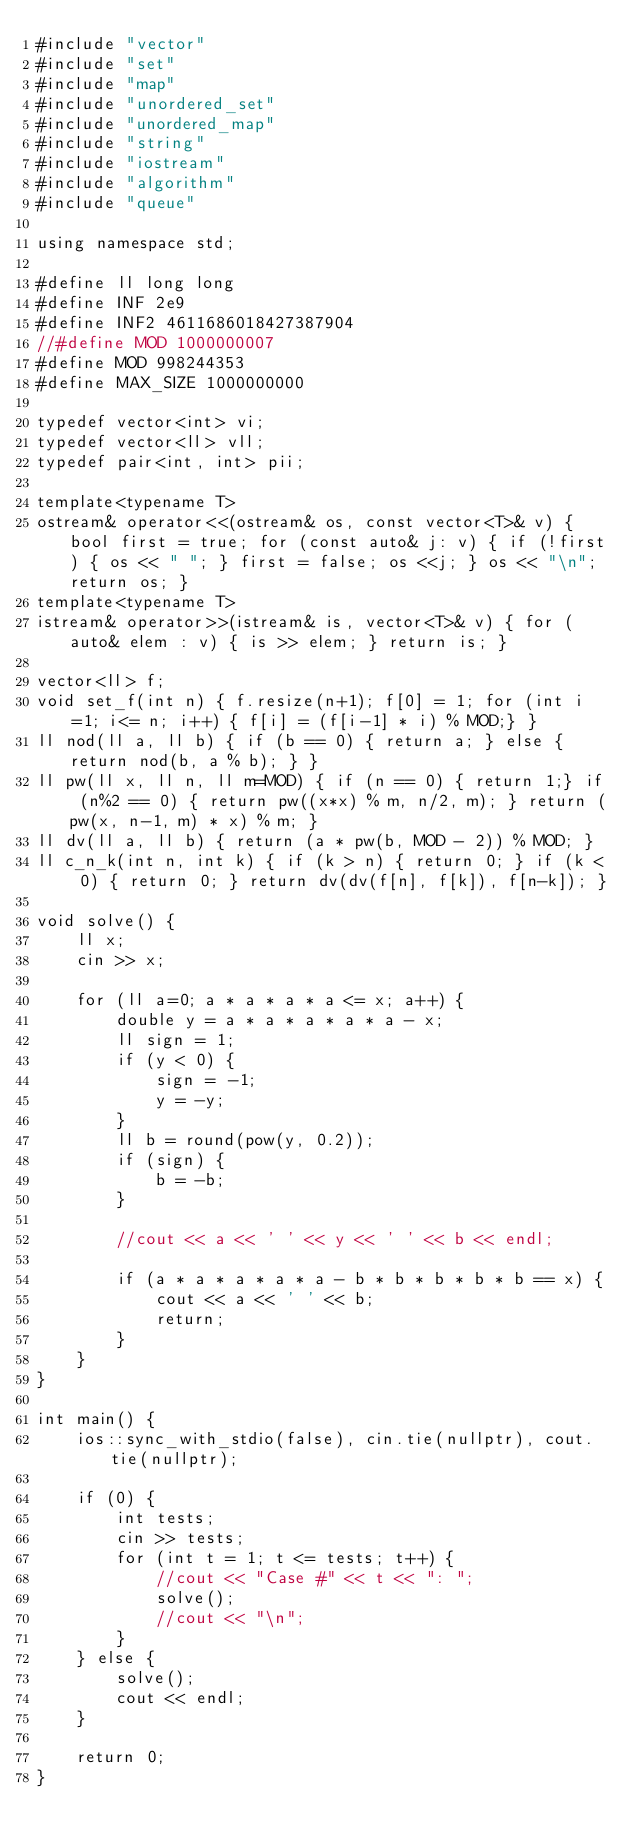Convert code to text. <code><loc_0><loc_0><loc_500><loc_500><_C++_>#include "vector"
#include "set"
#include "map"
#include "unordered_set"
#include "unordered_map"
#include "string"
#include "iostream"
#include "algorithm"
#include "queue"

using namespace std;

#define ll long long
#define INF 2e9
#define INF2 4611686018427387904
//#define MOD 1000000007
#define MOD 998244353
#define MAX_SIZE 1000000000

typedef vector<int> vi;
typedef vector<ll> vll;
typedef pair<int, int> pii;

template<typename T>
ostream& operator<<(ostream& os, const vector<T>& v) { bool first = true; for (const auto& j: v) { if (!first) { os << " "; } first = false; os <<j; } os << "\n"; return os; }
template<typename T>
istream& operator>>(istream& is, vector<T>& v) { for (auto& elem : v) { is >> elem; } return is; }

vector<ll> f;
void set_f(int n) { f.resize(n+1); f[0] = 1; for (int i=1; i<= n; i++) { f[i] = (f[i-1] * i) % MOD;} }
ll nod(ll a, ll b) { if (b == 0) { return a; } else { return nod(b, a % b); } }
ll pw(ll x, ll n, ll m=MOD) { if (n == 0) { return 1;} if (n%2 == 0) { return pw((x*x) % m, n/2, m); } return (pw(x, n-1, m) * x) % m; }
ll dv(ll a, ll b) { return (a * pw(b, MOD - 2)) % MOD; }
ll c_n_k(int n, int k) { if (k > n) { return 0; } if (k < 0) { return 0; } return dv(dv(f[n], f[k]), f[n-k]); }

void solve() {
    ll x;
    cin >> x;

    for (ll a=0; a * a * a * a <= x; a++) {
        double y = a * a * a * a * a - x;
        ll sign = 1;
        if (y < 0) {
            sign = -1;
            y = -y;
        }
        ll b = round(pow(y, 0.2));
        if (sign) {
            b = -b;
        }

        //cout << a << ' ' << y << ' ' << b << endl;

        if (a * a * a * a * a - b * b * b * b * b == x) {
            cout << a << ' ' << b;
            return;
        }
    }
}

int main() {
    ios::sync_with_stdio(false), cin.tie(nullptr), cout.tie(nullptr);

    if (0) {
        int tests;
        cin >> tests;
        for (int t = 1; t <= tests; t++) {
            //cout << "Case #" << t << ": ";
            solve();
            //cout << "\n";
        }
    } else {
        solve();
        cout << endl;
    }

    return 0;
}</code> 